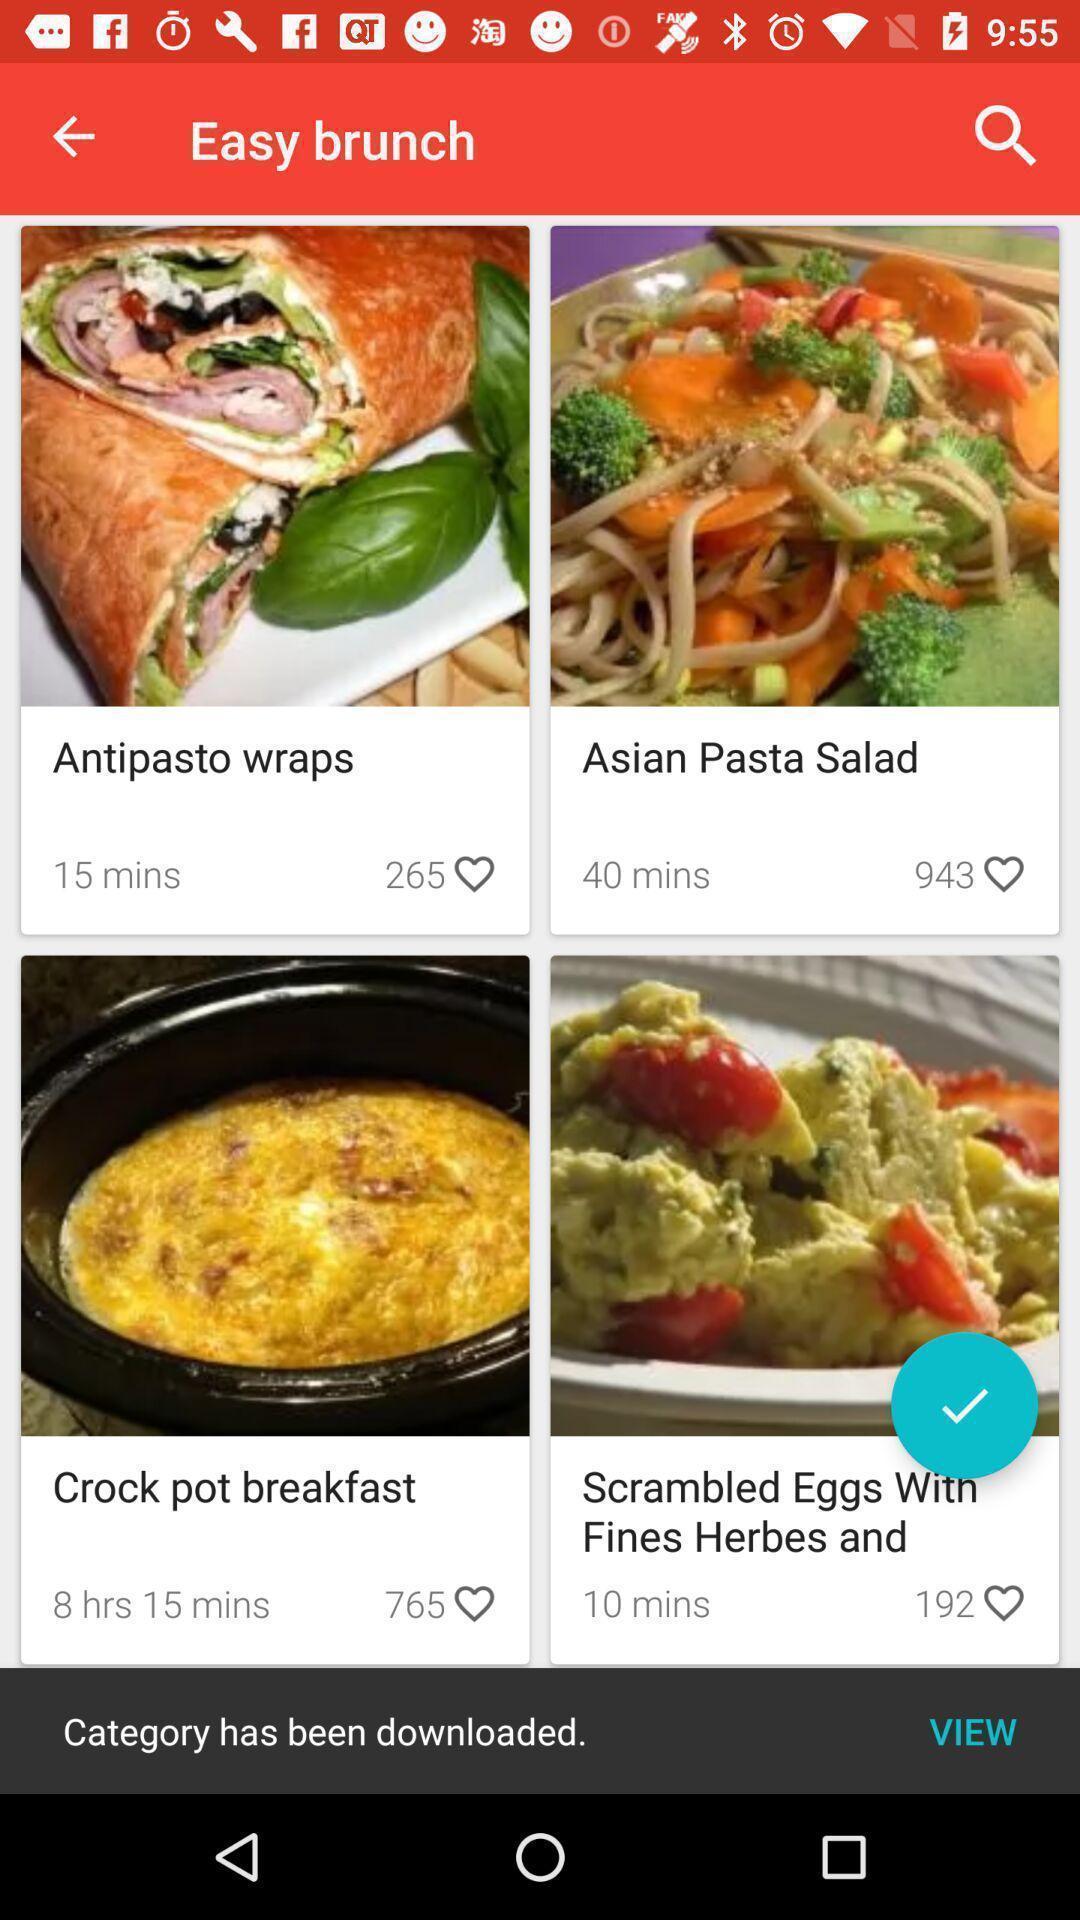What details can you identify in this image? Screen showing easy brunch recipes. 